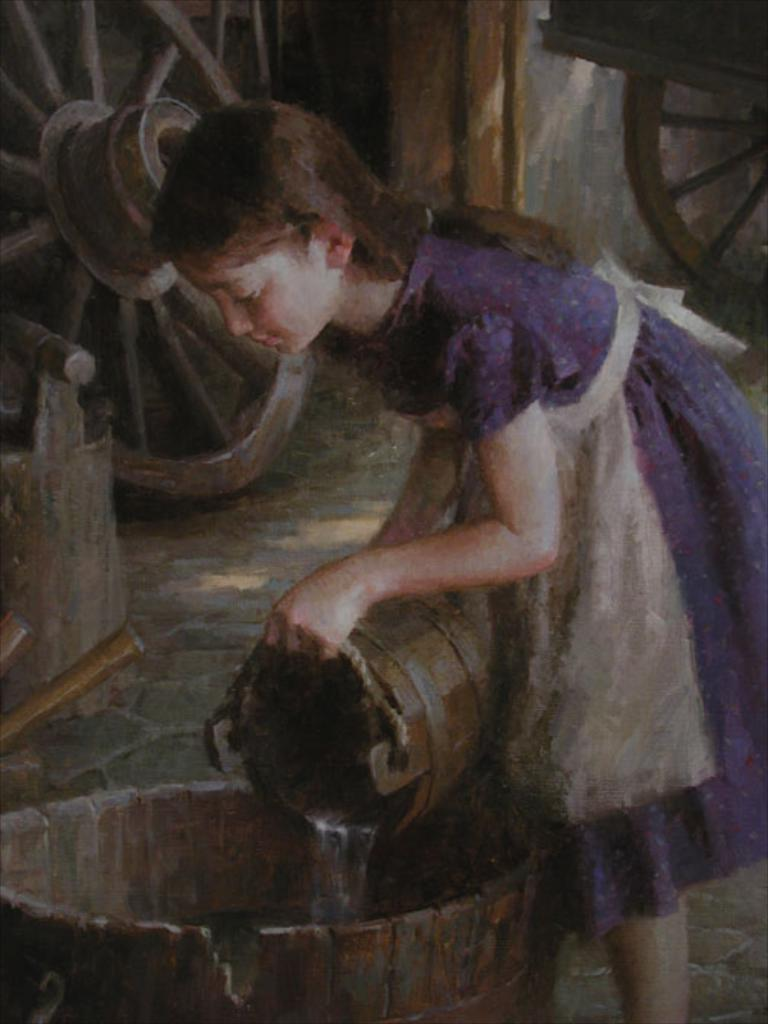What type of artwork is depicted in the image? The image is a painting. Who or what is the main subject of the painting? There is a girl in the painting. What is the girl doing in the painting? The girl is pouring water in a tub. Can you describe the contents of the tub? There is an unidentified object in the tub. What else can be seen near the girl in the painting? There are wheels beside the girl. What type of drug is the girl using in the painting? There is no indication of any drug use in the painting; the girl is pouring water in a tub. 